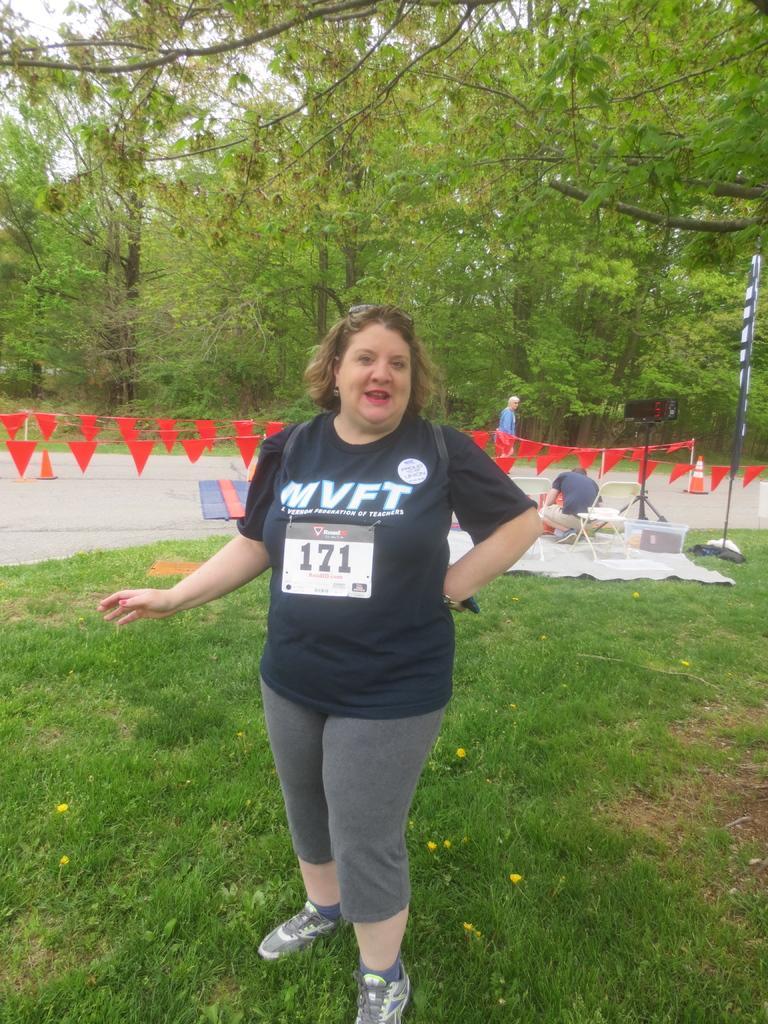Can you describe this image briefly? This picture is taken from outside of the city. In this image, in the middle, we can see a woman wearing a black color shirt and she is also wearing a backpack is standing on the grass. On the right side, we can see a man is in squat position and the man is on the white color mat, on the mat, we can see a basket. In the background, we can see flags, person, trees. At the top, we can see a sky, at the bottom, we can see a pole, road and a grass. 